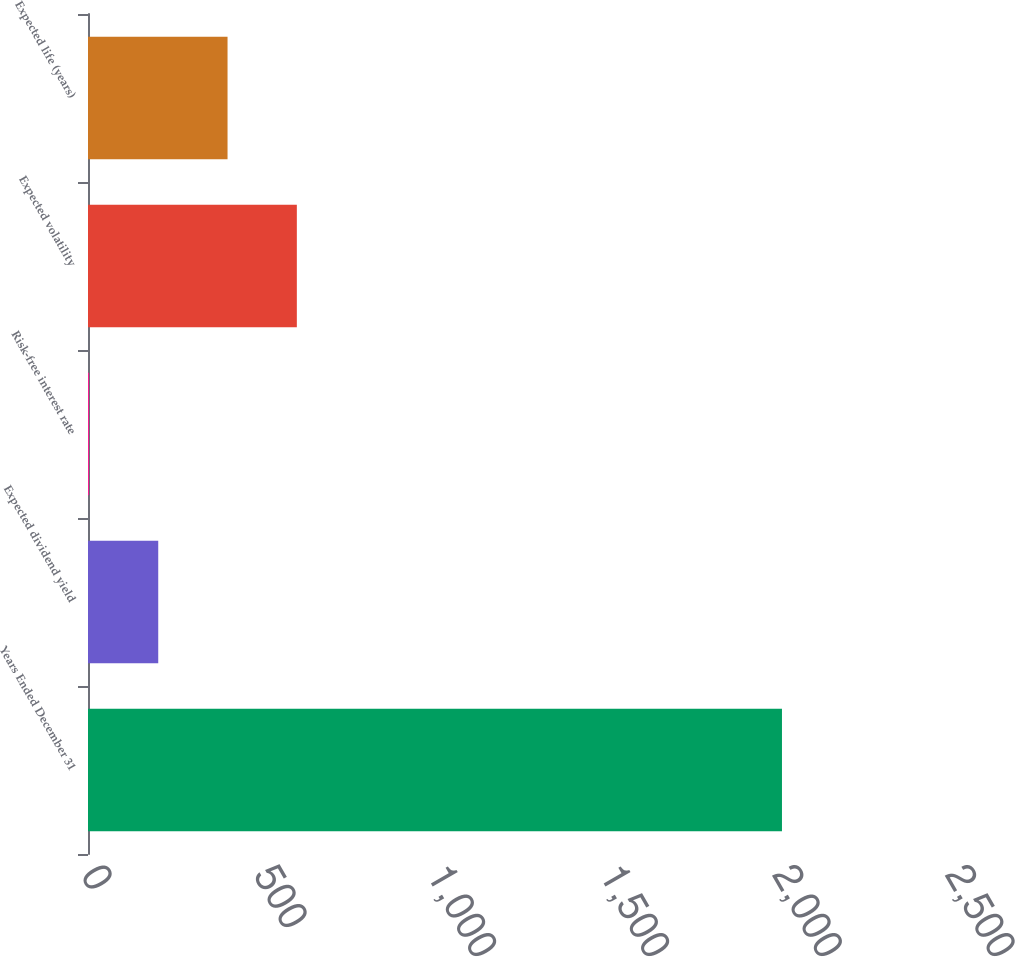Convert chart to OTSL. <chart><loc_0><loc_0><loc_500><loc_500><bar_chart><fcel>Years Ended December 31<fcel>Expected dividend yield<fcel>Risk-free interest rate<fcel>Expected volatility<fcel>Expected life (years)<nl><fcel>2008<fcel>203.23<fcel>2.7<fcel>604.29<fcel>403.76<nl></chart> 